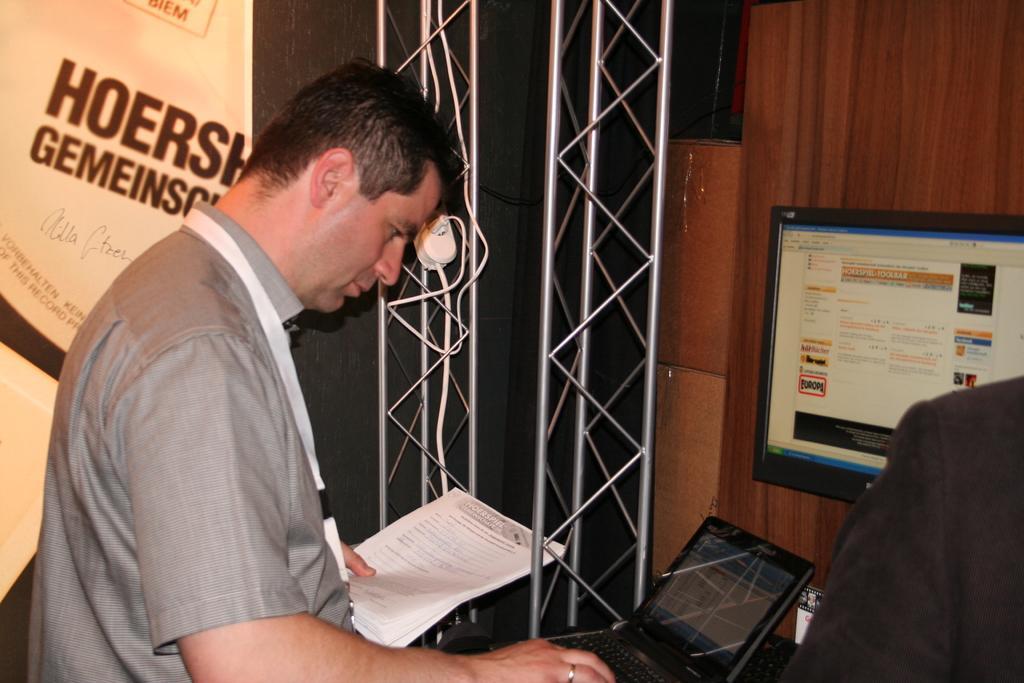Can you describe this image briefly? There is a person holding papers and operating a laptop in the foreground, there is another person and a monitor on the right side. There is a poster, it seems like poles and wires in the background area. 